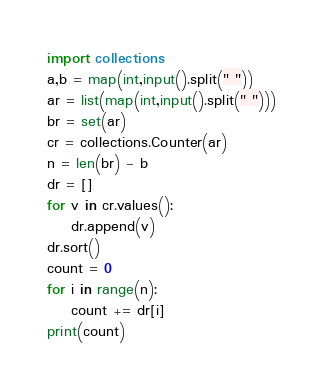Convert code to text. <code><loc_0><loc_0><loc_500><loc_500><_Python_>import collections
a,b = map(int,input().split(" "))
ar = list(map(int,input().split(" ")))
br = set(ar)
cr = collections.Counter(ar)
n = len(br) - b
dr = []
for v in cr.values():
    dr.append(v)
dr.sort()
count = 0
for i in range(n):
    count += dr[i]
print(count)</code> 